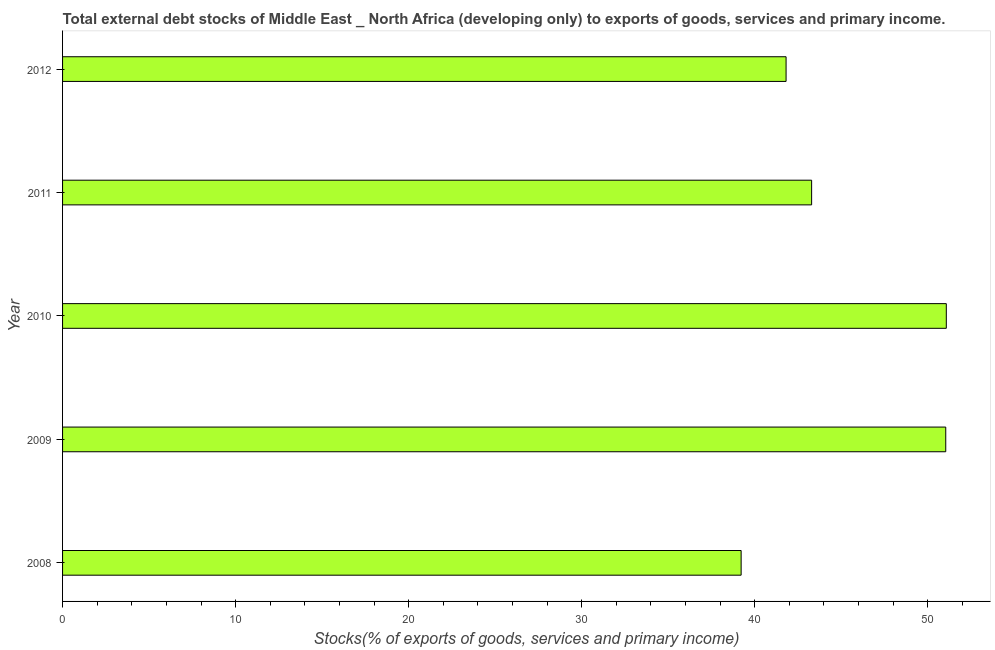Does the graph contain grids?
Keep it short and to the point. No. What is the title of the graph?
Keep it short and to the point. Total external debt stocks of Middle East _ North Africa (developing only) to exports of goods, services and primary income. What is the label or title of the X-axis?
Ensure brevity in your answer.  Stocks(% of exports of goods, services and primary income). What is the label or title of the Y-axis?
Provide a succinct answer. Year. What is the external debt stocks in 2011?
Ensure brevity in your answer.  43.29. Across all years, what is the maximum external debt stocks?
Your response must be concise. 51.07. Across all years, what is the minimum external debt stocks?
Provide a succinct answer. 39.22. What is the sum of the external debt stocks?
Your response must be concise. 226.43. What is the difference between the external debt stocks in 2009 and 2010?
Provide a short and direct response. -0.03. What is the average external debt stocks per year?
Make the answer very short. 45.29. What is the median external debt stocks?
Offer a very short reply. 43.29. Do a majority of the years between 2008 and 2010 (inclusive) have external debt stocks greater than 46 %?
Provide a succinct answer. Yes. What is the ratio of the external debt stocks in 2008 to that in 2009?
Your answer should be very brief. 0.77. What is the difference between the highest and the second highest external debt stocks?
Provide a short and direct response. 0.03. Is the sum of the external debt stocks in 2010 and 2011 greater than the maximum external debt stocks across all years?
Your answer should be compact. Yes. What is the difference between the highest and the lowest external debt stocks?
Offer a terse response. 11.86. Are all the bars in the graph horizontal?
Keep it short and to the point. Yes. How many years are there in the graph?
Provide a succinct answer. 5. What is the difference between two consecutive major ticks on the X-axis?
Your answer should be very brief. 10. Are the values on the major ticks of X-axis written in scientific E-notation?
Give a very brief answer. No. What is the Stocks(% of exports of goods, services and primary income) in 2008?
Offer a very short reply. 39.22. What is the Stocks(% of exports of goods, services and primary income) in 2009?
Give a very brief answer. 51.04. What is the Stocks(% of exports of goods, services and primary income) of 2010?
Offer a terse response. 51.07. What is the Stocks(% of exports of goods, services and primary income) in 2011?
Provide a succinct answer. 43.29. What is the Stocks(% of exports of goods, services and primary income) of 2012?
Your response must be concise. 41.81. What is the difference between the Stocks(% of exports of goods, services and primary income) in 2008 and 2009?
Ensure brevity in your answer.  -11.82. What is the difference between the Stocks(% of exports of goods, services and primary income) in 2008 and 2010?
Give a very brief answer. -11.86. What is the difference between the Stocks(% of exports of goods, services and primary income) in 2008 and 2011?
Your answer should be very brief. -4.07. What is the difference between the Stocks(% of exports of goods, services and primary income) in 2008 and 2012?
Offer a terse response. -2.6. What is the difference between the Stocks(% of exports of goods, services and primary income) in 2009 and 2010?
Provide a short and direct response. -0.03. What is the difference between the Stocks(% of exports of goods, services and primary income) in 2009 and 2011?
Ensure brevity in your answer.  7.75. What is the difference between the Stocks(% of exports of goods, services and primary income) in 2009 and 2012?
Keep it short and to the point. 9.23. What is the difference between the Stocks(% of exports of goods, services and primary income) in 2010 and 2011?
Give a very brief answer. 7.78. What is the difference between the Stocks(% of exports of goods, services and primary income) in 2010 and 2012?
Give a very brief answer. 9.26. What is the difference between the Stocks(% of exports of goods, services and primary income) in 2011 and 2012?
Make the answer very short. 1.48. What is the ratio of the Stocks(% of exports of goods, services and primary income) in 2008 to that in 2009?
Provide a succinct answer. 0.77. What is the ratio of the Stocks(% of exports of goods, services and primary income) in 2008 to that in 2010?
Provide a short and direct response. 0.77. What is the ratio of the Stocks(% of exports of goods, services and primary income) in 2008 to that in 2011?
Offer a terse response. 0.91. What is the ratio of the Stocks(% of exports of goods, services and primary income) in 2008 to that in 2012?
Offer a very short reply. 0.94. What is the ratio of the Stocks(% of exports of goods, services and primary income) in 2009 to that in 2011?
Your answer should be compact. 1.18. What is the ratio of the Stocks(% of exports of goods, services and primary income) in 2009 to that in 2012?
Your answer should be very brief. 1.22. What is the ratio of the Stocks(% of exports of goods, services and primary income) in 2010 to that in 2011?
Provide a succinct answer. 1.18. What is the ratio of the Stocks(% of exports of goods, services and primary income) in 2010 to that in 2012?
Ensure brevity in your answer.  1.22. What is the ratio of the Stocks(% of exports of goods, services and primary income) in 2011 to that in 2012?
Make the answer very short. 1.03. 